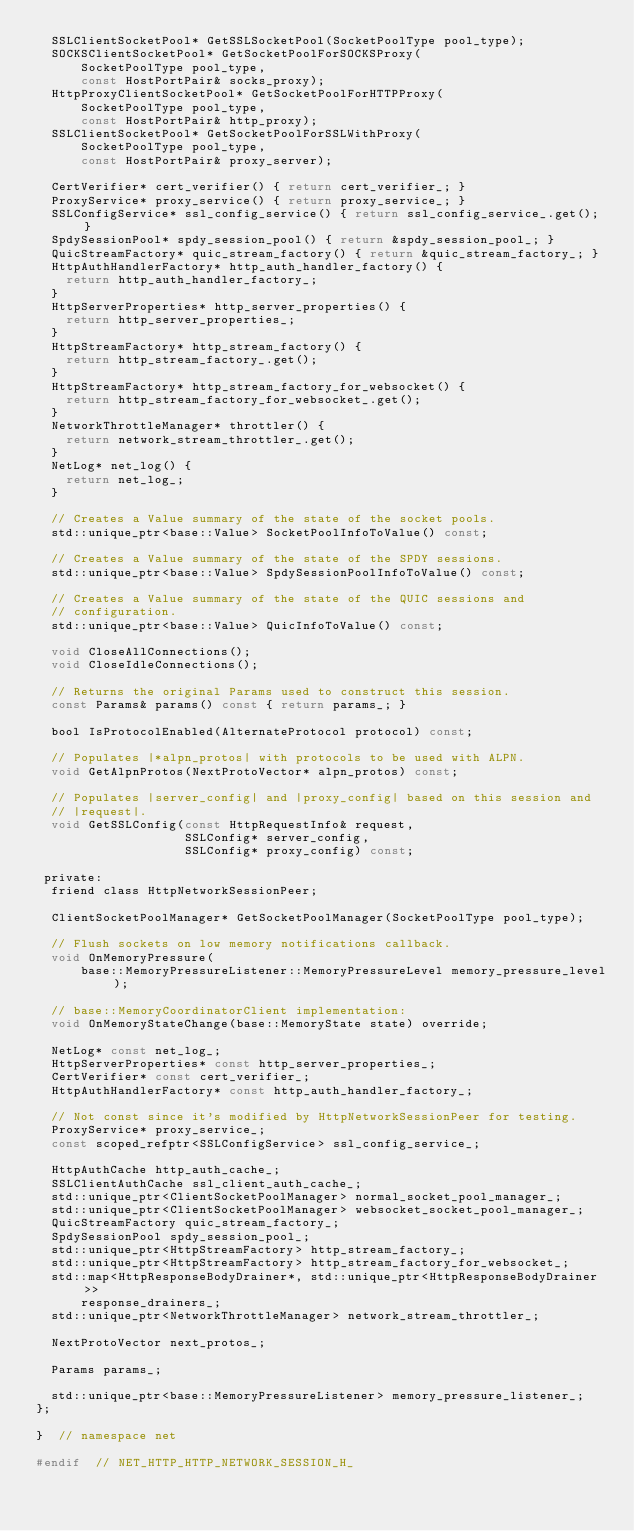Convert code to text. <code><loc_0><loc_0><loc_500><loc_500><_C_>  SSLClientSocketPool* GetSSLSocketPool(SocketPoolType pool_type);
  SOCKSClientSocketPool* GetSocketPoolForSOCKSProxy(
      SocketPoolType pool_type,
      const HostPortPair& socks_proxy);
  HttpProxyClientSocketPool* GetSocketPoolForHTTPProxy(
      SocketPoolType pool_type,
      const HostPortPair& http_proxy);
  SSLClientSocketPool* GetSocketPoolForSSLWithProxy(
      SocketPoolType pool_type,
      const HostPortPair& proxy_server);

  CertVerifier* cert_verifier() { return cert_verifier_; }
  ProxyService* proxy_service() { return proxy_service_; }
  SSLConfigService* ssl_config_service() { return ssl_config_service_.get(); }
  SpdySessionPool* spdy_session_pool() { return &spdy_session_pool_; }
  QuicStreamFactory* quic_stream_factory() { return &quic_stream_factory_; }
  HttpAuthHandlerFactory* http_auth_handler_factory() {
    return http_auth_handler_factory_;
  }
  HttpServerProperties* http_server_properties() {
    return http_server_properties_;
  }
  HttpStreamFactory* http_stream_factory() {
    return http_stream_factory_.get();
  }
  HttpStreamFactory* http_stream_factory_for_websocket() {
    return http_stream_factory_for_websocket_.get();
  }
  NetworkThrottleManager* throttler() {
    return network_stream_throttler_.get();
  }
  NetLog* net_log() {
    return net_log_;
  }

  // Creates a Value summary of the state of the socket pools.
  std::unique_ptr<base::Value> SocketPoolInfoToValue() const;

  // Creates a Value summary of the state of the SPDY sessions.
  std::unique_ptr<base::Value> SpdySessionPoolInfoToValue() const;

  // Creates a Value summary of the state of the QUIC sessions and
  // configuration.
  std::unique_ptr<base::Value> QuicInfoToValue() const;

  void CloseAllConnections();
  void CloseIdleConnections();

  // Returns the original Params used to construct this session.
  const Params& params() const { return params_; }

  bool IsProtocolEnabled(AlternateProtocol protocol) const;

  // Populates |*alpn_protos| with protocols to be used with ALPN.
  void GetAlpnProtos(NextProtoVector* alpn_protos) const;

  // Populates |server_config| and |proxy_config| based on this session and
  // |request|.
  void GetSSLConfig(const HttpRequestInfo& request,
                    SSLConfig* server_config,
                    SSLConfig* proxy_config) const;

 private:
  friend class HttpNetworkSessionPeer;

  ClientSocketPoolManager* GetSocketPoolManager(SocketPoolType pool_type);

  // Flush sockets on low memory notifications callback.
  void OnMemoryPressure(
      base::MemoryPressureListener::MemoryPressureLevel memory_pressure_level);

  // base::MemoryCoordinatorClient implementation:
  void OnMemoryStateChange(base::MemoryState state) override;

  NetLog* const net_log_;
  HttpServerProperties* const http_server_properties_;
  CertVerifier* const cert_verifier_;
  HttpAuthHandlerFactory* const http_auth_handler_factory_;

  // Not const since it's modified by HttpNetworkSessionPeer for testing.
  ProxyService* proxy_service_;
  const scoped_refptr<SSLConfigService> ssl_config_service_;

  HttpAuthCache http_auth_cache_;
  SSLClientAuthCache ssl_client_auth_cache_;
  std::unique_ptr<ClientSocketPoolManager> normal_socket_pool_manager_;
  std::unique_ptr<ClientSocketPoolManager> websocket_socket_pool_manager_;
  QuicStreamFactory quic_stream_factory_;
  SpdySessionPool spdy_session_pool_;
  std::unique_ptr<HttpStreamFactory> http_stream_factory_;
  std::unique_ptr<HttpStreamFactory> http_stream_factory_for_websocket_;
  std::map<HttpResponseBodyDrainer*, std::unique_ptr<HttpResponseBodyDrainer>>
      response_drainers_;
  std::unique_ptr<NetworkThrottleManager> network_stream_throttler_;

  NextProtoVector next_protos_;

  Params params_;

  std::unique_ptr<base::MemoryPressureListener> memory_pressure_listener_;
};

}  // namespace net

#endif  // NET_HTTP_HTTP_NETWORK_SESSION_H_
</code> 